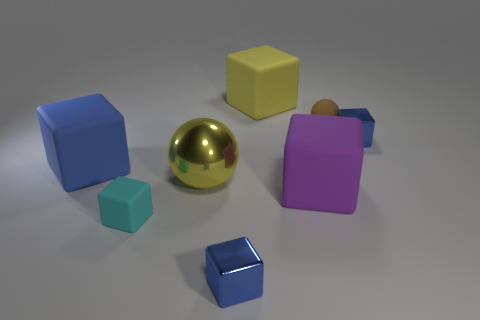Subtract all brown cylinders. How many blue blocks are left? 3 Subtract all purple cubes. How many cubes are left? 5 Subtract all cyan matte blocks. How many blocks are left? 5 Subtract all green cubes. Subtract all red cylinders. How many cubes are left? 6 Add 1 purple rubber blocks. How many objects exist? 9 Subtract all blocks. How many objects are left? 2 Subtract 0 green cubes. How many objects are left? 8 Subtract all small matte things. Subtract all yellow matte objects. How many objects are left? 5 Add 6 purple rubber cubes. How many purple rubber cubes are left? 7 Add 3 small yellow things. How many small yellow things exist? 3 